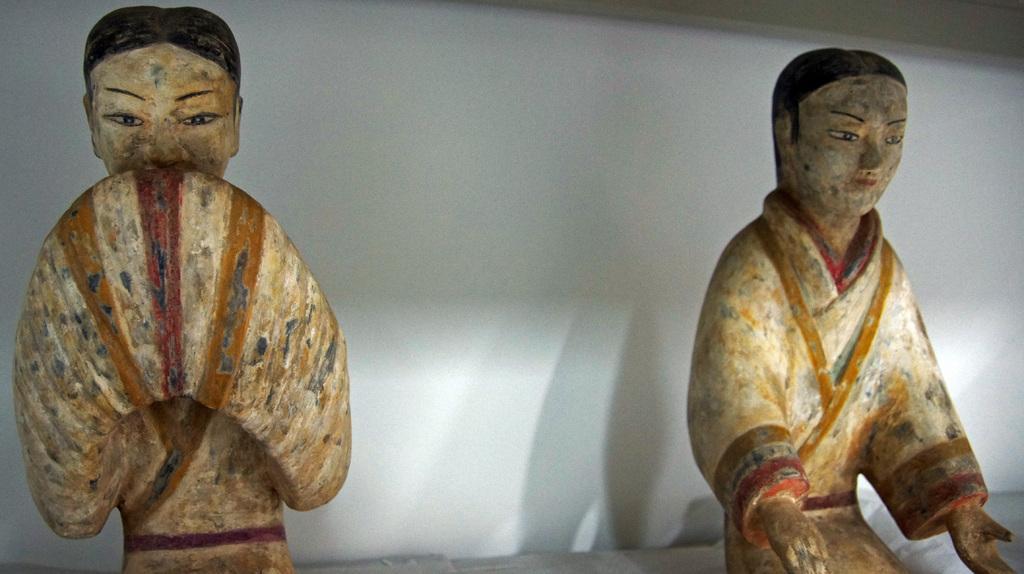Can you describe this image briefly? In this picture I can see 2 sculptures in front and I can see the white color background. 